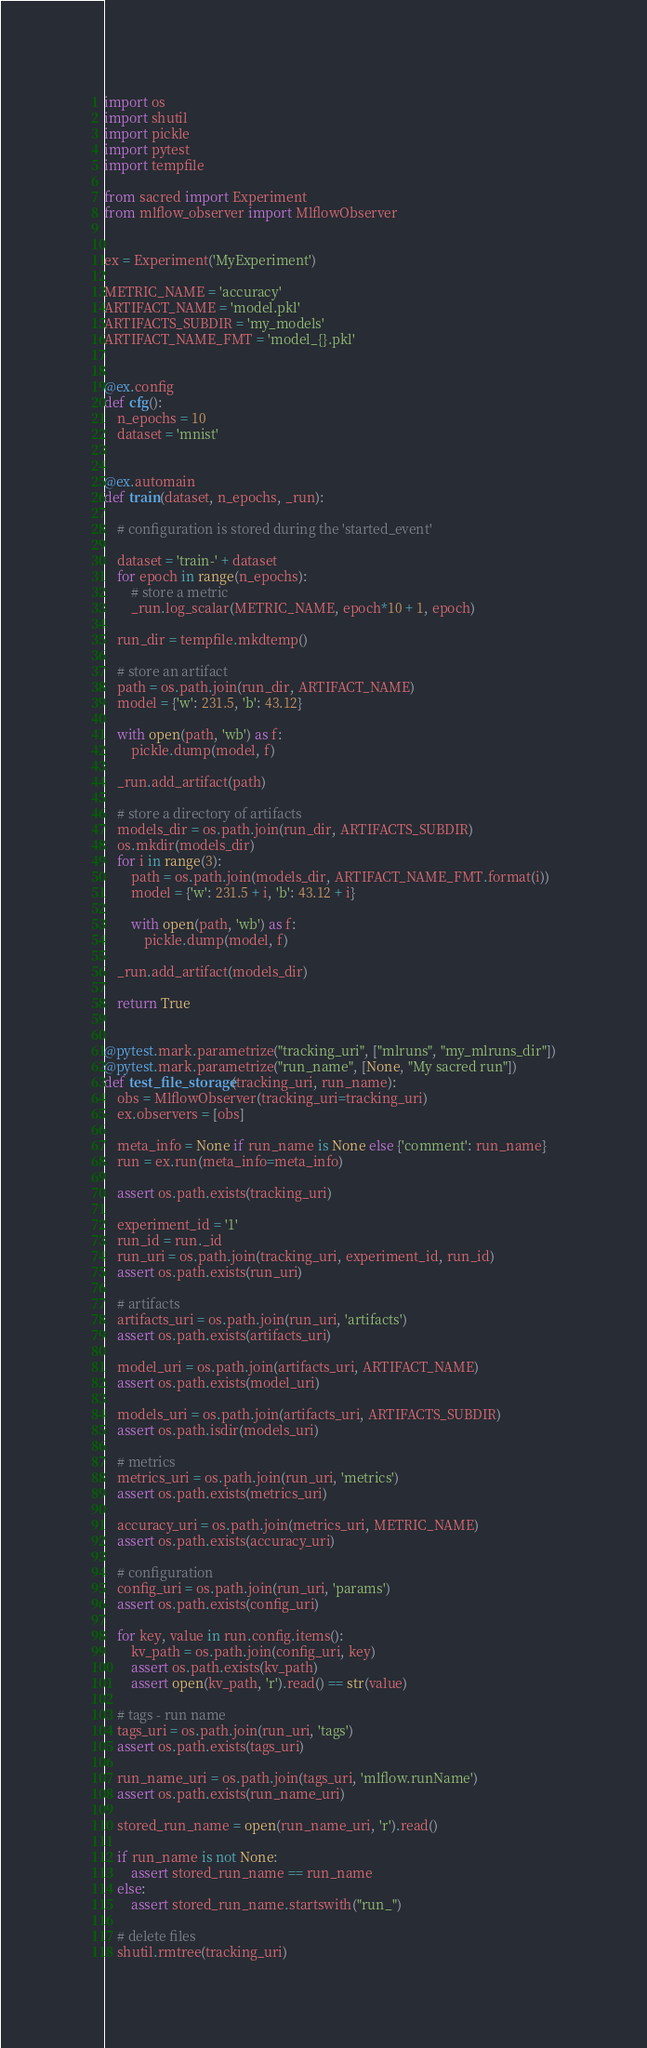Convert code to text. <code><loc_0><loc_0><loc_500><loc_500><_Python_>import os
import shutil
import pickle
import pytest
import tempfile

from sacred import Experiment
from mlflow_observer import MlflowObserver


ex = Experiment('MyExperiment')

METRIC_NAME = 'accuracy'
ARTIFACT_NAME = 'model.pkl'
ARTIFACTS_SUBDIR = 'my_models'
ARTIFACT_NAME_FMT = 'model_{}.pkl'


@ex.config
def cfg():
    n_epochs = 10
    dataset = 'mnist'


@ex.automain
def train(dataset, n_epochs, _run):

    # configuration is stored during the 'started_event'

    dataset = 'train-' + dataset
    for epoch in range(n_epochs):
        # store a metric
        _run.log_scalar(METRIC_NAME, epoch*10 + 1, epoch)

    run_dir = tempfile.mkdtemp()

    # store an artifact
    path = os.path.join(run_dir, ARTIFACT_NAME)
    model = {'w': 231.5, 'b': 43.12}

    with open(path, 'wb') as f:
        pickle.dump(model, f)

    _run.add_artifact(path)

    # store a directory of artifacts
    models_dir = os.path.join(run_dir, ARTIFACTS_SUBDIR)
    os.mkdir(models_dir)
    for i in range(3):
        path = os.path.join(models_dir, ARTIFACT_NAME_FMT.format(i))
        model = {'w': 231.5 + i, 'b': 43.12 + i}

        with open(path, 'wb') as f:
            pickle.dump(model, f)

    _run.add_artifact(models_dir)

    return True


@pytest.mark.parametrize("tracking_uri", ["mlruns", "my_mlruns_dir"])
@pytest.mark.parametrize("run_name", [None, "My sacred run"])
def test_file_storage(tracking_uri, run_name):
    obs = MlflowObserver(tracking_uri=tracking_uri)
    ex.observers = [obs]

    meta_info = None if run_name is None else {'comment': run_name}
    run = ex.run(meta_info=meta_info)

    assert os.path.exists(tracking_uri)

    experiment_id = '1'
    run_id = run._id
    run_uri = os.path.join(tracking_uri, experiment_id, run_id)
    assert os.path.exists(run_uri)

    # artifacts
    artifacts_uri = os.path.join(run_uri, 'artifacts')
    assert os.path.exists(artifacts_uri)

    model_uri = os.path.join(artifacts_uri, ARTIFACT_NAME)
    assert os.path.exists(model_uri)

    models_uri = os.path.join(artifacts_uri, ARTIFACTS_SUBDIR)
    assert os.path.isdir(models_uri)

    # metrics
    metrics_uri = os.path.join(run_uri, 'metrics')
    assert os.path.exists(metrics_uri)

    accuracy_uri = os.path.join(metrics_uri, METRIC_NAME)
    assert os.path.exists(accuracy_uri)

    # configuration
    config_uri = os.path.join(run_uri, 'params')
    assert os.path.exists(config_uri)

    for key, value in run.config.items():
        kv_path = os.path.join(config_uri, key)
        assert os.path.exists(kv_path)
        assert open(kv_path, 'r').read() == str(value)

    # tags - run name
    tags_uri = os.path.join(run_uri, 'tags')
    assert os.path.exists(tags_uri)

    run_name_uri = os.path.join(tags_uri, 'mlflow.runName')
    assert os.path.exists(run_name_uri)

    stored_run_name = open(run_name_uri, 'r').read()

    if run_name is not None:
        assert stored_run_name == run_name
    else:
        assert stored_run_name.startswith("run_")

    # delete files
    shutil.rmtree(tracking_uri)
</code> 